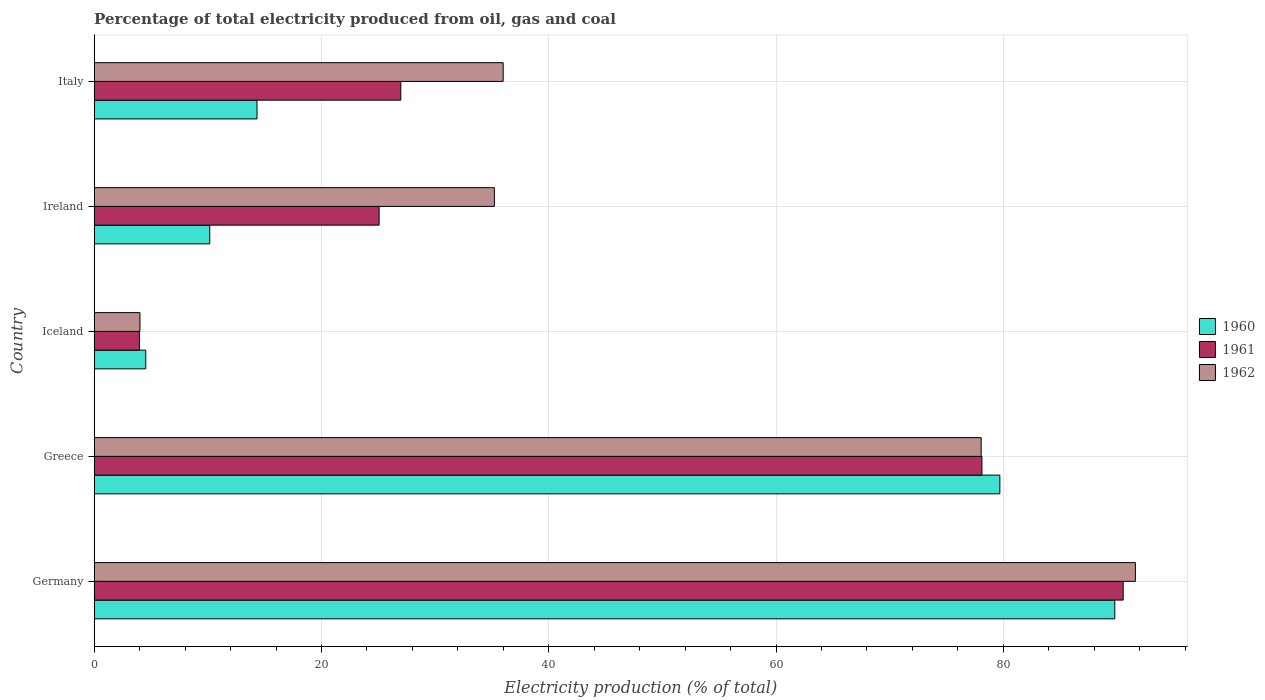How many different coloured bars are there?
Ensure brevity in your answer.  3. Are the number of bars per tick equal to the number of legend labels?
Provide a succinct answer. Yes. How many bars are there on the 2nd tick from the top?
Offer a terse response. 3. How many bars are there on the 3rd tick from the bottom?
Ensure brevity in your answer.  3. What is the electricity production in in 1960 in Ireland?
Offer a very short reply. 10.17. Across all countries, what is the maximum electricity production in in 1962?
Provide a succinct answer. 91.62. Across all countries, what is the minimum electricity production in in 1961?
Make the answer very short. 3.98. In which country was the electricity production in in 1962 minimum?
Your answer should be compact. Iceland. What is the total electricity production in in 1960 in the graph?
Your answer should be compact. 198.53. What is the difference between the electricity production in in 1962 in Germany and that in Italy?
Give a very brief answer. 55.63. What is the difference between the electricity production in in 1960 in Ireland and the electricity production in in 1962 in Iceland?
Give a very brief answer. 6.14. What is the average electricity production in in 1961 per country?
Offer a very short reply. 44.94. What is the difference between the electricity production in in 1961 and electricity production in in 1960 in Greece?
Your answer should be very brief. -1.58. What is the ratio of the electricity production in in 1960 in Iceland to that in Ireland?
Keep it short and to the point. 0.45. Is the electricity production in in 1960 in Iceland less than that in Ireland?
Offer a very short reply. Yes. What is the difference between the highest and the second highest electricity production in in 1961?
Your answer should be very brief. 12.43. What is the difference between the highest and the lowest electricity production in in 1961?
Your answer should be very brief. 86.56. In how many countries, is the electricity production in in 1961 greater than the average electricity production in in 1961 taken over all countries?
Provide a short and direct response. 2. Is the sum of the electricity production in in 1961 in Iceland and Italy greater than the maximum electricity production in in 1962 across all countries?
Offer a terse response. No. Is it the case that in every country, the sum of the electricity production in in 1961 and electricity production in in 1962 is greater than the electricity production in in 1960?
Make the answer very short. Yes. Does the graph contain any zero values?
Ensure brevity in your answer.  No. Does the graph contain grids?
Your answer should be very brief. Yes. Where does the legend appear in the graph?
Offer a terse response. Center right. How many legend labels are there?
Your response must be concise. 3. What is the title of the graph?
Ensure brevity in your answer.  Percentage of total electricity produced from oil, gas and coal. What is the label or title of the X-axis?
Provide a succinct answer. Electricity production (% of total). What is the label or title of the Y-axis?
Make the answer very short. Country. What is the Electricity production (% of total) of 1960 in Germany?
Offer a very short reply. 89.81. What is the Electricity production (% of total) of 1961 in Germany?
Ensure brevity in your answer.  90.54. What is the Electricity production (% of total) in 1962 in Germany?
Give a very brief answer. 91.62. What is the Electricity production (% of total) in 1960 in Greece?
Your answer should be compact. 79.69. What is the Electricity production (% of total) in 1961 in Greece?
Offer a very short reply. 78.12. What is the Electricity production (% of total) of 1962 in Greece?
Offer a terse response. 78.05. What is the Electricity production (% of total) of 1960 in Iceland?
Keep it short and to the point. 4.54. What is the Electricity production (% of total) in 1961 in Iceland?
Your answer should be very brief. 3.98. What is the Electricity production (% of total) of 1962 in Iceland?
Give a very brief answer. 4.03. What is the Electricity production (% of total) of 1960 in Ireland?
Keep it short and to the point. 10.17. What is the Electricity production (% of total) of 1961 in Ireland?
Ensure brevity in your answer.  25.07. What is the Electricity production (% of total) in 1962 in Ireland?
Keep it short and to the point. 35.21. What is the Electricity production (% of total) of 1960 in Italy?
Provide a short and direct response. 14.33. What is the Electricity production (% of total) in 1961 in Italy?
Ensure brevity in your answer.  26.98. What is the Electricity production (% of total) of 1962 in Italy?
Give a very brief answer. 35.99. Across all countries, what is the maximum Electricity production (% of total) of 1960?
Your answer should be very brief. 89.81. Across all countries, what is the maximum Electricity production (% of total) of 1961?
Offer a terse response. 90.54. Across all countries, what is the maximum Electricity production (% of total) of 1962?
Make the answer very short. 91.62. Across all countries, what is the minimum Electricity production (% of total) of 1960?
Offer a very short reply. 4.54. Across all countries, what is the minimum Electricity production (% of total) in 1961?
Make the answer very short. 3.98. Across all countries, what is the minimum Electricity production (% of total) of 1962?
Give a very brief answer. 4.03. What is the total Electricity production (% of total) of 1960 in the graph?
Give a very brief answer. 198.53. What is the total Electricity production (% of total) of 1961 in the graph?
Ensure brevity in your answer.  224.69. What is the total Electricity production (% of total) in 1962 in the graph?
Your response must be concise. 244.89. What is the difference between the Electricity production (% of total) in 1960 in Germany and that in Greece?
Your answer should be very brief. 10.11. What is the difference between the Electricity production (% of total) in 1961 in Germany and that in Greece?
Offer a terse response. 12.43. What is the difference between the Electricity production (% of total) in 1962 in Germany and that in Greece?
Keep it short and to the point. 13.57. What is the difference between the Electricity production (% of total) of 1960 in Germany and that in Iceland?
Your answer should be compact. 85.27. What is the difference between the Electricity production (% of total) of 1961 in Germany and that in Iceland?
Ensure brevity in your answer.  86.56. What is the difference between the Electricity production (% of total) in 1962 in Germany and that in Iceland?
Ensure brevity in your answer.  87.59. What is the difference between the Electricity production (% of total) in 1960 in Germany and that in Ireland?
Ensure brevity in your answer.  79.64. What is the difference between the Electricity production (% of total) in 1961 in Germany and that in Ireland?
Your answer should be very brief. 65.47. What is the difference between the Electricity production (% of total) in 1962 in Germany and that in Ireland?
Your answer should be compact. 56.41. What is the difference between the Electricity production (% of total) of 1960 in Germany and that in Italy?
Keep it short and to the point. 75.48. What is the difference between the Electricity production (% of total) in 1961 in Germany and that in Italy?
Provide a succinct answer. 63.57. What is the difference between the Electricity production (% of total) in 1962 in Germany and that in Italy?
Your answer should be compact. 55.63. What is the difference between the Electricity production (% of total) of 1960 in Greece and that in Iceland?
Your response must be concise. 75.16. What is the difference between the Electricity production (% of total) of 1961 in Greece and that in Iceland?
Your answer should be very brief. 74.14. What is the difference between the Electricity production (% of total) of 1962 in Greece and that in Iceland?
Your answer should be compact. 74.02. What is the difference between the Electricity production (% of total) in 1960 in Greece and that in Ireland?
Your answer should be very brief. 69.53. What is the difference between the Electricity production (% of total) of 1961 in Greece and that in Ireland?
Your response must be concise. 53.05. What is the difference between the Electricity production (% of total) of 1962 in Greece and that in Ireland?
Your answer should be compact. 42.84. What is the difference between the Electricity production (% of total) in 1960 in Greece and that in Italy?
Your response must be concise. 65.37. What is the difference between the Electricity production (% of total) in 1961 in Greece and that in Italy?
Provide a short and direct response. 51.14. What is the difference between the Electricity production (% of total) in 1962 in Greece and that in Italy?
Your answer should be very brief. 42.06. What is the difference between the Electricity production (% of total) of 1960 in Iceland and that in Ireland?
Provide a short and direct response. -5.63. What is the difference between the Electricity production (% of total) of 1961 in Iceland and that in Ireland?
Offer a very short reply. -21.09. What is the difference between the Electricity production (% of total) of 1962 in Iceland and that in Ireland?
Provide a short and direct response. -31.19. What is the difference between the Electricity production (% of total) in 1960 in Iceland and that in Italy?
Your answer should be compact. -9.79. What is the difference between the Electricity production (% of total) in 1961 in Iceland and that in Italy?
Your answer should be very brief. -23. What is the difference between the Electricity production (% of total) of 1962 in Iceland and that in Italy?
Your answer should be very brief. -31.96. What is the difference between the Electricity production (% of total) of 1960 in Ireland and that in Italy?
Offer a terse response. -4.16. What is the difference between the Electricity production (% of total) in 1961 in Ireland and that in Italy?
Give a very brief answer. -1.91. What is the difference between the Electricity production (% of total) of 1962 in Ireland and that in Italy?
Your response must be concise. -0.78. What is the difference between the Electricity production (% of total) of 1960 in Germany and the Electricity production (% of total) of 1961 in Greece?
Ensure brevity in your answer.  11.69. What is the difference between the Electricity production (% of total) of 1960 in Germany and the Electricity production (% of total) of 1962 in Greece?
Keep it short and to the point. 11.76. What is the difference between the Electricity production (% of total) in 1961 in Germany and the Electricity production (% of total) in 1962 in Greece?
Give a very brief answer. 12.49. What is the difference between the Electricity production (% of total) of 1960 in Germany and the Electricity production (% of total) of 1961 in Iceland?
Provide a succinct answer. 85.83. What is the difference between the Electricity production (% of total) of 1960 in Germany and the Electricity production (% of total) of 1962 in Iceland?
Provide a short and direct response. 85.78. What is the difference between the Electricity production (% of total) of 1961 in Germany and the Electricity production (% of total) of 1962 in Iceland?
Keep it short and to the point. 86.52. What is the difference between the Electricity production (% of total) in 1960 in Germany and the Electricity production (% of total) in 1961 in Ireland?
Provide a succinct answer. 64.74. What is the difference between the Electricity production (% of total) of 1960 in Germany and the Electricity production (% of total) of 1962 in Ireland?
Your answer should be compact. 54.6. What is the difference between the Electricity production (% of total) in 1961 in Germany and the Electricity production (% of total) in 1962 in Ireland?
Make the answer very short. 55.33. What is the difference between the Electricity production (% of total) in 1960 in Germany and the Electricity production (% of total) in 1961 in Italy?
Offer a terse response. 62.83. What is the difference between the Electricity production (% of total) in 1960 in Germany and the Electricity production (% of total) in 1962 in Italy?
Your answer should be very brief. 53.82. What is the difference between the Electricity production (% of total) of 1961 in Germany and the Electricity production (% of total) of 1962 in Italy?
Ensure brevity in your answer.  54.56. What is the difference between the Electricity production (% of total) of 1960 in Greece and the Electricity production (% of total) of 1961 in Iceland?
Your answer should be very brief. 75.71. What is the difference between the Electricity production (% of total) in 1960 in Greece and the Electricity production (% of total) in 1962 in Iceland?
Keep it short and to the point. 75.67. What is the difference between the Electricity production (% of total) in 1961 in Greece and the Electricity production (% of total) in 1962 in Iceland?
Give a very brief answer. 74.09. What is the difference between the Electricity production (% of total) in 1960 in Greece and the Electricity production (% of total) in 1961 in Ireland?
Offer a very short reply. 54.62. What is the difference between the Electricity production (% of total) of 1960 in Greece and the Electricity production (% of total) of 1962 in Ireland?
Your answer should be compact. 44.48. What is the difference between the Electricity production (% of total) of 1961 in Greece and the Electricity production (% of total) of 1962 in Ireland?
Your response must be concise. 42.91. What is the difference between the Electricity production (% of total) of 1960 in Greece and the Electricity production (% of total) of 1961 in Italy?
Give a very brief answer. 52.72. What is the difference between the Electricity production (% of total) of 1960 in Greece and the Electricity production (% of total) of 1962 in Italy?
Give a very brief answer. 43.71. What is the difference between the Electricity production (% of total) of 1961 in Greece and the Electricity production (% of total) of 1962 in Italy?
Make the answer very short. 42.13. What is the difference between the Electricity production (% of total) in 1960 in Iceland and the Electricity production (% of total) in 1961 in Ireland?
Keep it short and to the point. -20.53. What is the difference between the Electricity production (% of total) of 1960 in Iceland and the Electricity production (% of total) of 1962 in Ireland?
Make the answer very short. -30.67. What is the difference between the Electricity production (% of total) of 1961 in Iceland and the Electricity production (% of total) of 1962 in Ireland?
Provide a succinct answer. -31.23. What is the difference between the Electricity production (% of total) of 1960 in Iceland and the Electricity production (% of total) of 1961 in Italy?
Keep it short and to the point. -22.44. What is the difference between the Electricity production (% of total) in 1960 in Iceland and the Electricity production (% of total) in 1962 in Italy?
Your answer should be compact. -31.45. What is the difference between the Electricity production (% of total) of 1961 in Iceland and the Electricity production (% of total) of 1962 in Italy?
Give a very brief answer. -32.01. What is the difference between the Electricity production (% of total) of 1960 in Ireland and the Electricity production (% of total) of 1961 in Italy?
Offer a terse response. -16.81. What is the difference between the Electricity production (% of total) of 1960 in Ireland and the Electricity production (% of total) of 1962 in Italy?
Keep it short and to the point. -25.82. What is the difference between the Electricity production (% of total) in 1961 in Ireland and the Electricity production (% of total) in 1962 in Italy?
Offer a terse response. -10.92. What is the average Electricity production (% of total) of 1960 per country?
Keep it short and to the point. 39.71. What is the average Electricity production (% of total) of 1961 per country?
Offer a very short reply. 44.94. What is the average Electricity production (% of total) of 1962 per country?
Provide a succinct answer. 48.98. What is the difference between the Electricity production (% of total) of 1960 and Electricity production (% of total) of 1961 in Germany?
Your response must be concise. -0.74. What is the difference between the Electricity production (% of total) of 1960 and Electricity production (% of total) of 1962 in Germany?
Provide a short and direct response. -1.81. What is the difference between the Electricity production (% of total) in 1961 and Electricity production (% of total) in 1962 in Germany?
Ensure brevity in your answer.  -1.07. What is the difference between the Electricity production (% of total) of 1960 and Electricity production (% of total) of 1961 in Greece?
Your answer should be very brief. 1.58. What is the difference between the Electricity production (% of total) of 1960 and Electricity production (% of total) of 1962 in Greece?
Your answer should be compact. 1.64. What is the difference between the Electricity production (% of total) in 1961 and Electricity production (% of total) in 1962 in Greece?
Provide a short and direct response. 0.07. What is the difference between the Electricity production (% of total) of 1960 and Electricity production (% of total) of 1961 in Iceland?
Provide a succinct answer. 0.56. What is the difference between the Electricity production (% of total) of 1960 and Electricity production (% of total) of 1962 in Iceland?
Make the answer very short. 0.51. What is the difference between the Electricity production (% of total) in 1961 and Electricity production (% of total) in 1962 in Iceland?
Make the answer very short. -0.05. What is the difference between the Electricity production (% of total) of 1960 and Electricity production (% of total) of 1961 in Ireland?
Your response must be concise. -14.9. What is the difference between the Electricity production (% of total) of 1960 and Electricity production (% of total) of 1962 in Ireland?
Offer a terse response. -25.04. What is the difference between the Electricity production (% of total) in 1961 and Electricity production (% of total) in 1962 in Ireland?
Keep it short and to the point. -10.14. What is the difference between the Electricity production (% of total) of 1960 and Electricity production (% of total) of 1961 in Italy?
Keep it short and to the point. -12.65. What is the difference between the Electricity production (% of total) of 1960 and Electricity production (% of total) of 1962 in Italy?
Offer a terse response. -21.66. What is the difference between the Electricity production (% of total) of 1961 and Electricity production (% of total) of 1962 in Italy?
Your response must be concise. -9.01. What is the ratio of the Electricity production (% of total) in 1960 in Germany to that in Greece?
Offer a very short reply. 1.13. What is the ratio of the Electricity production (% of total) in 1961 in Germany to that in Greece?
Your answer should be very brief. 1.16. What is the ratio of the Electricity production (% of total) in 1962 in Germany to that in Greece?
Your answer should be very brief. 1.17. What is the ratio of the Electricity production (% of total) of 1960 in Germany to that in Iceland?
Provide a succinct answer. 19.79. What is the ratio of the Electricity production (% of total) in 1961 in Germany to that in Iceland?
Ensure brevity in your answer.  22.75. What is the ratio of the Electricity production (% of total) of 1962 in Germany to that in Iceland?
Your response must be concise. 22.76. What is the ratio of the Electricity production (% of total) of 1960 in Germany to that in Ireland?
Your answer should be compact. 8.83. What is the ratio of the Electricity production (% of total) in 1961 in Germany to that in Ireland?
Your answer should be compact. 3.61. What is the ratio of the Electricity production (% of total) of 1962 in Germany to that in Ireland?
Your answer should be very brief. 2.6. What is the ratio of the Electricity production (% of total) of 1960 in Germany to that in Italy?
Your response must be concise. 6.27. What is the ratio of the Electricity production (% of total) of 1961 in Germany to that in Italy?
Ensure brevity in your answer.  3.36. What is the ratio of the Electricity production (% of total) of 1962 in Germany to that in Italy?
Offer a very short reply. 2.55. What is the ratio of the Electricity production (% of total) of 1960 in Greece to that in Iceland?
Your answer should be very brief. 17.56. What is the ratio of the Electricity production (% of total) in 1961 in Greece to that in Iceland?
Your response must be concise. 19.63. What is the ratio of the Electricity production (% of total) of 1962 in Greece to that in Iceland?
Provide a short and direct response. 19.39. What is the ratio of the Electricity production (% of total) in 1960 in Greece to that in Ireland?
Offer a very short reply. 7.84. What is the ratio of the Electricity production (% of total) of 1961 in Greece to that in Ireland?
Offer a very short reply. 3.12. What is the ratio of the Electricity production (% of total) in 1962 in Greece to that in Ireland?
Offer a very short reply. 2.22. What is the ratio of the Electricity production (% of total) of 1960 in Greece to that in Italy?
Ensure brevity in your answer.  5.56. What is the ratio of the Electricity production (% of total) in 1961 in Greece to that in Italy?
Offer a terse response. 2.9. What is the ratio of the Electricity production (% of total) in 1962 in Greece to that in Italy?
Give a very brief answer. 2.17. What is the ratio of the Electricity production (% of total) of 1960 in Iceland to that in Ireland?
Keep it short and to the point. 0.45. What is the ratio of the Electricity production (% of total) of 1961 in Iceland to that in Ireland?
Offer a very short reply. 0.16. What is the ratio of the Electricity production (% of total) of 1962 in Iceland to that in Ireland?
Give a very brief answer. 0.11. What is the ratio of the Electricity production (% of total) in 1960 in Iceland to that in Italy?
Offer a very short reply. 0.32. What is the ratio of the Electricity production (% of total) in 1961 in Iceland to that in Italy?
Your response must be concise. 0.15. What is the ratio of the Electricity production (% of total) in 1962 in Iceland to that in Italy?
Keep it short and to the point. 0.11. What is the ratio of the Electricity production (% of total) of 1960 in Ireland to that in Italy?
Your response must be concise. 0.71. What is the ratio of the Electricity production (% of total) of 1961 in Ireland to that in Italy?
Your response must be concise. 0.93. What is the ratio of the Electricity production (% of total) of 1962 in Ireland to that in Italy?
Keep it short and to the point. 0.98. What is the difference between the highest and the second highest Electricity production (% of total) of 1960?
Give a very brief answer. 10.11. What is the difference between the highest and the second highest Electricity production (% of total) of 1961?
Keep it short and to the point. 12.43. What is the difference between the highest and the second highest Electricity production (% of total) in 1962?
Offer a very short reply. 13.57. What is the difference between the highest and the lowest Electricity production (% of total) of 1960?
Give a very brief answer. 85.27. What is the difference between the highest and the lowest Electricity production (% of total) in 1961?
Offer a very short reply. 86.56. What is the difference between the highest and the lowest Electricity production (% of total) in 1962?
Keep it short and to the point. 87.59. 